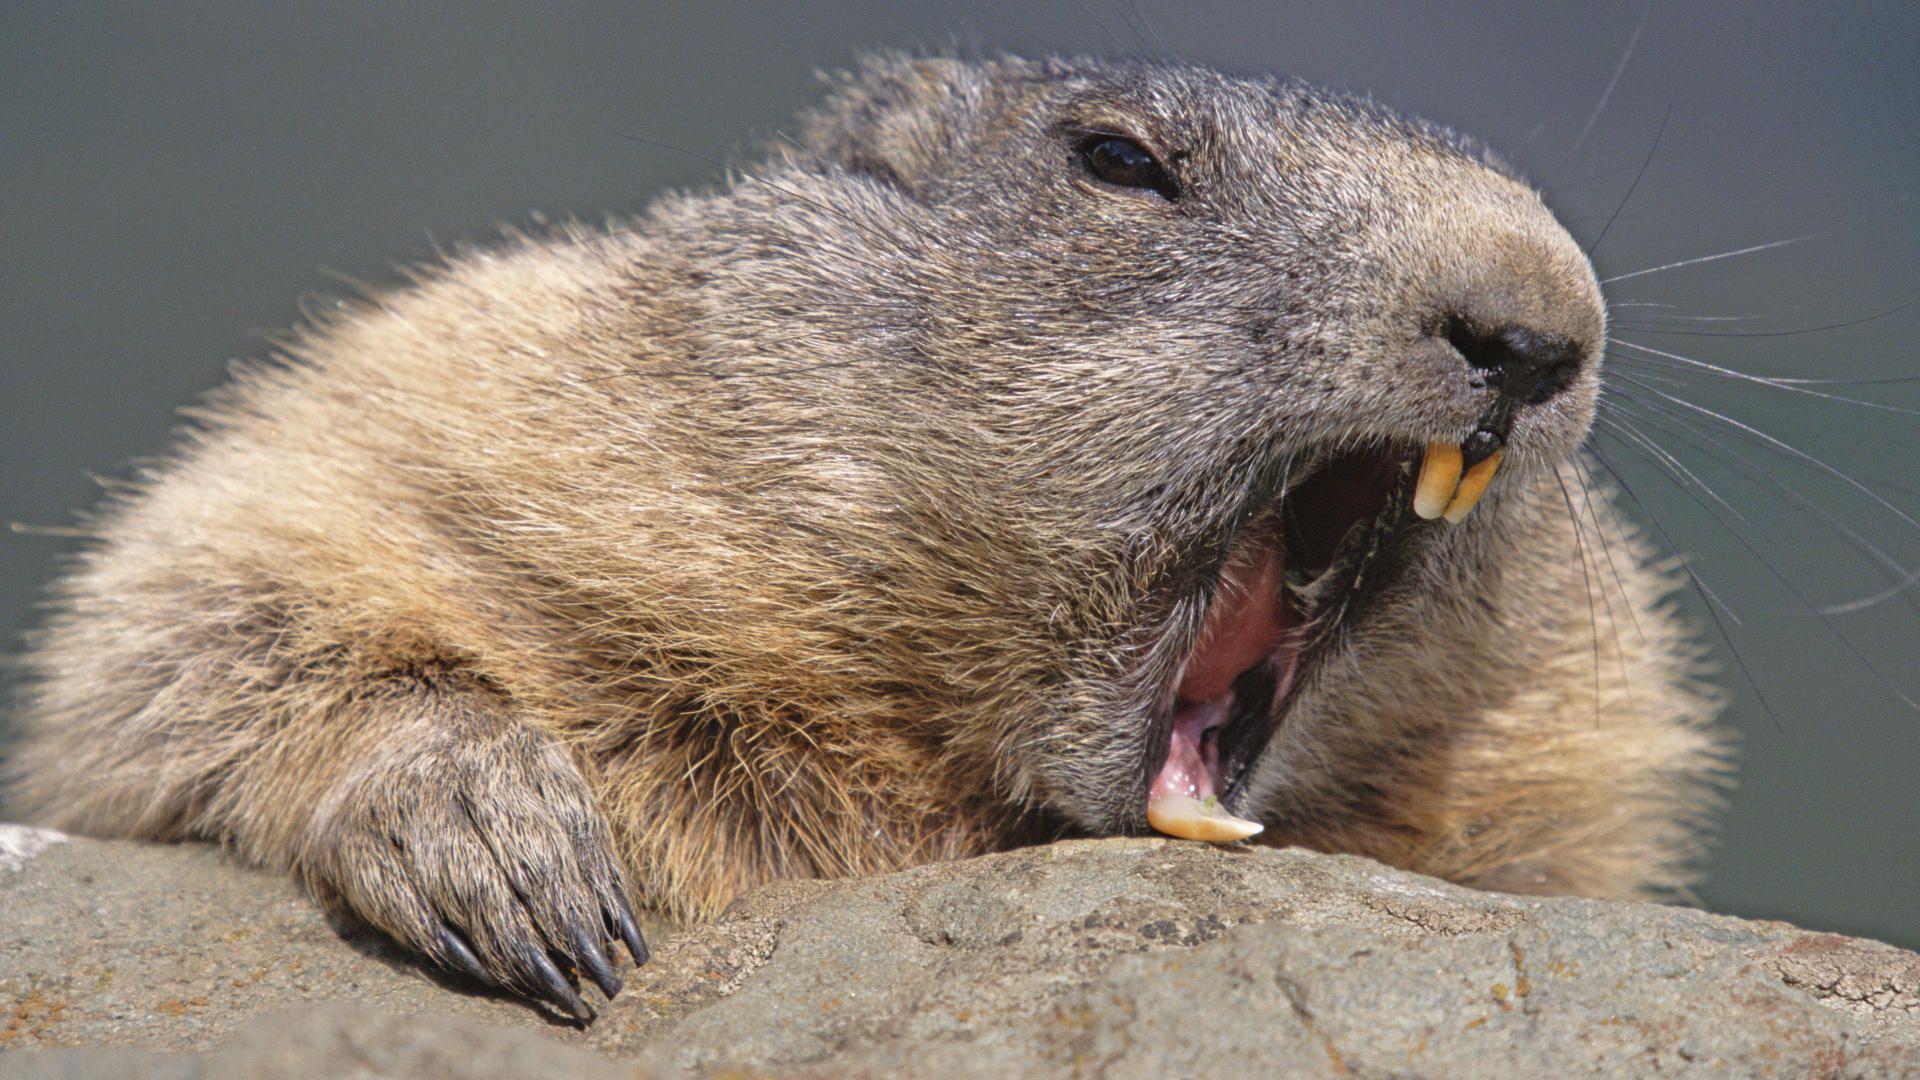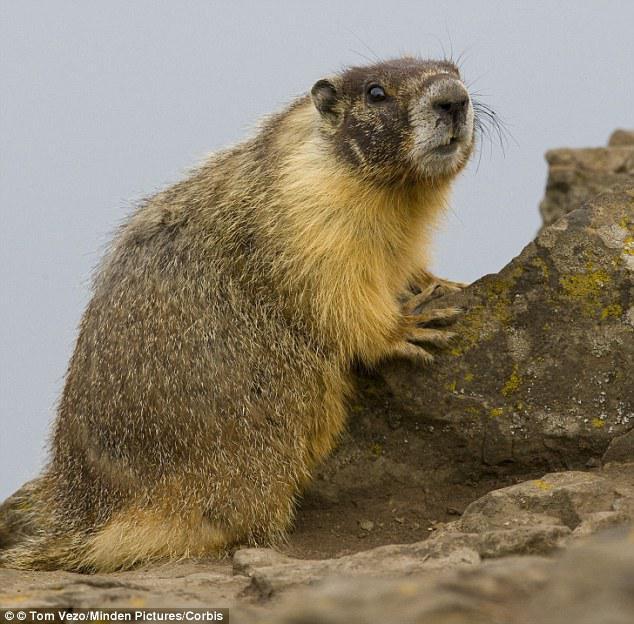The first image is the image on the left, the second image is the image on the right. Assess this claim about the two images: "There is at least one ground hog with its front paws resting on a rock.". Correct or not? Answer yes or no. Yes. The first image is the image on the left, the second image is the image on the right. Examine the images to the left and right. Is the description "An image shows a marmot standing upright, with its front paws hanging downward." accurate? Answer yes or no. No. 